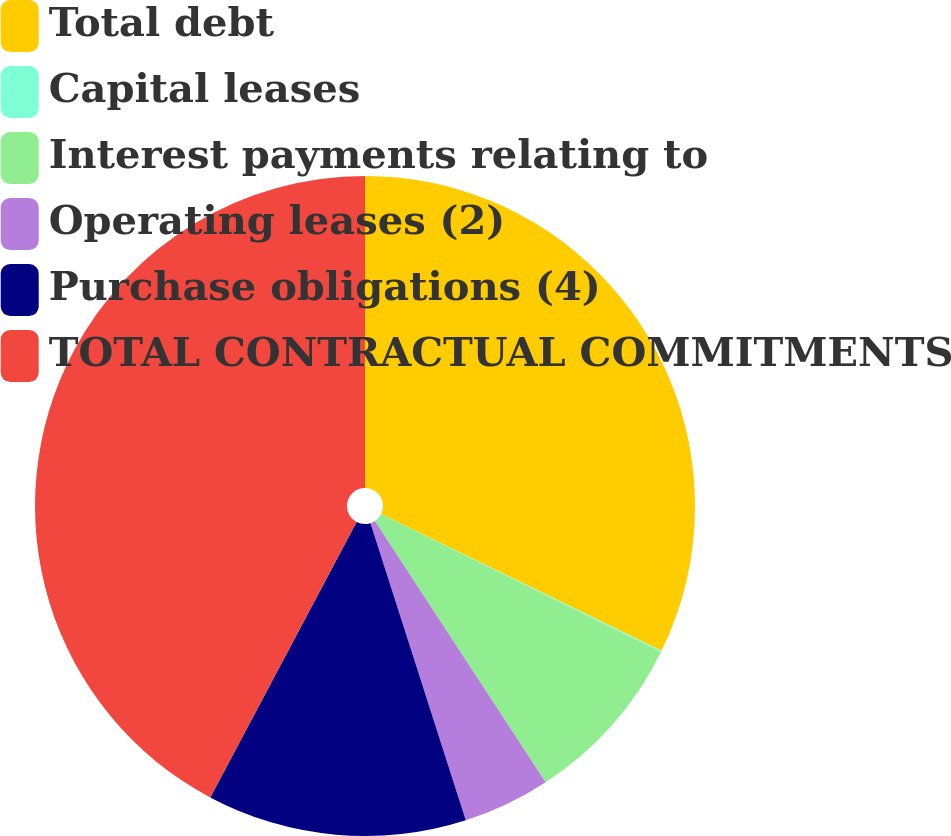<chart> <loc_0><loc_0><loc_500><loc_500><pie_chart><fcel>Total debt<fcel>Capital leases<fcel>Interest payments relating to<fcel>Operating leases (2)<fcel>Purchase obligations (4)<fcel>TOTAL CONTRACTUAL COMMITMENTS<nl><fcel>32.23%<fcel>0.06%<fcel>8.49%<fcel>4.28%<fcel>12.71%<fcel>42.23%<nl></chart> 